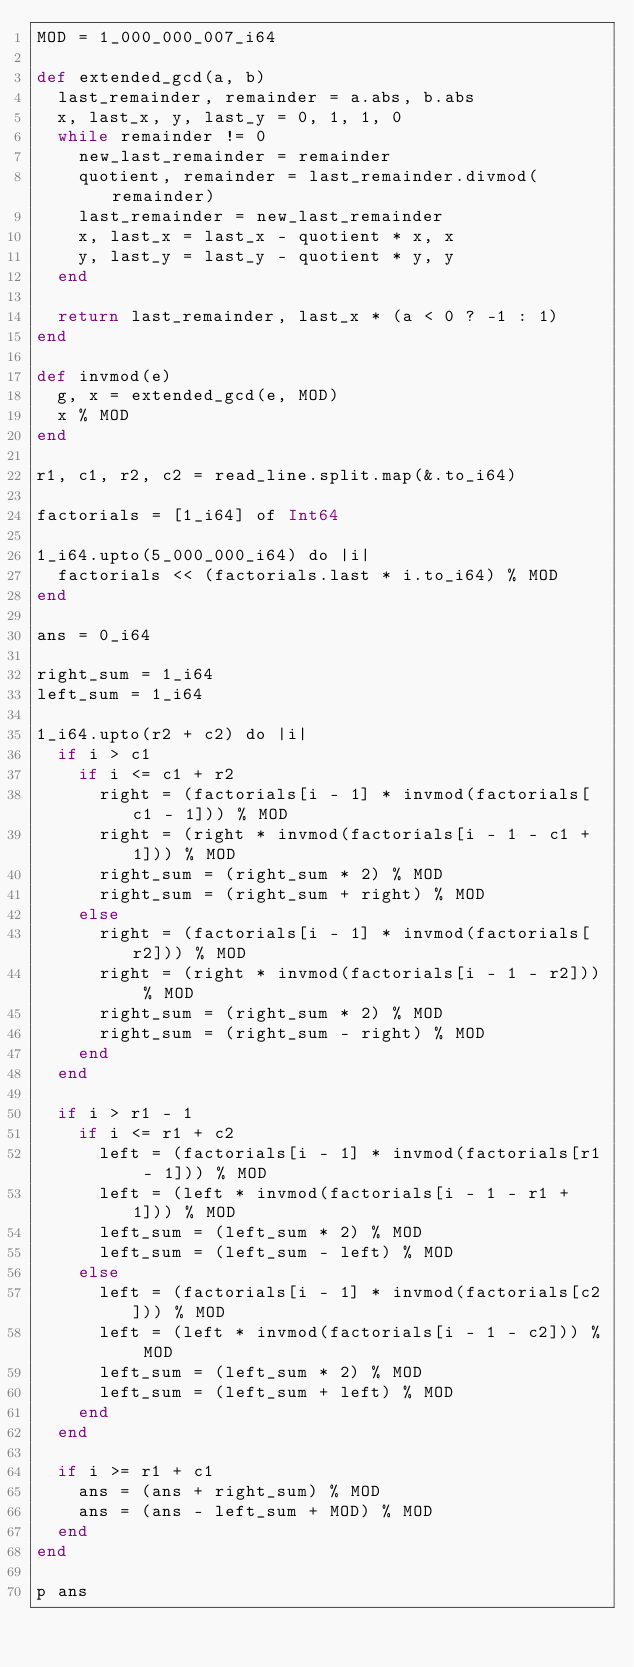<code> <loc_0><loc_0><loc_500><loc_500><_Crystal_>MOD = 1_000_000_007_i64

def extended_gcd(a, b)
  last_remainder, remainder = a.abs, b.abs
  x, last_x, y, last_y = 0, 1, 1, 0
  while remainder != 0
    new_last_remainder = remainder
    quotient, remainder = last_remainder.divmod(remainder)
    last_remainder = new_last_remainder
    x, last_x = last_x - quotient * x, x
    y, last_y = last_y - quotient * y, y
  end

  return last_remainder, last_x * (a < 0 ? -1 : 1)
end

def invmod(e)
  g, x = extended_gcd(e, MOD)
  x % MOD
end

r1, c1, r2, c2 = read_line.split.map(&.to_i64)

factorials = [1_i64] of Int64

1_i64.upto(5_000_000_i64) do |i|
  factorials << (factorials.last * i.to_i64) % MOD
end

ans = 0_i64

right_sum = 1_i64
left_sum = 1_i64

1_i64.upto(r2 + c2) do |i|
  if i > c1
    if i <= c1 + r2
      right = (factorials[i - 1] * invmod(factorials[c1 - 1])) % MOD
      right = (right * invmod(factorials[i - 1 - c1 + 1])) % MOD
      right_sum = (right_sum * 2) % MOD
      right_sum = (right_sum + right) % MOD
    else
      right = (factorials[i - 1] * invmod(factorials[r2])) % MOD
      right = (right * invmod(factorials[i - 1 - r2])) % MOD
      right_sum = (right_sum * 2) % MOD
      right_sum = (right_sum - right) % MOD
    end
  end

  if i > r1 - 1
    if i <= r1 + c2
      left = (factorials[i - 1] * invmod(factorials[r1 - 1])) % MOD
      left = (left * invmod(factorials[i - 1 - r1 + 1])) % MOD
      left_sum = (left_sum * 2) % MOD
      left_sum = (left_sum - left) % MOD
    else
      left = (factorials[i - 1] * invmod(factorials[c2])) % MOD
      left = (left * invmod(factorials[i - 1 - c2])) % MOD
      left_sum = (left_sum * 2) % MOD
      left_sum = (left_sum + left) % MOD
    end
  end

  if i >= r1 + c1
    ans = (ans + right_sum) % MOD
    ans = (ans - left_sum + MOD) % MOD
  end
end

p ans</code> 